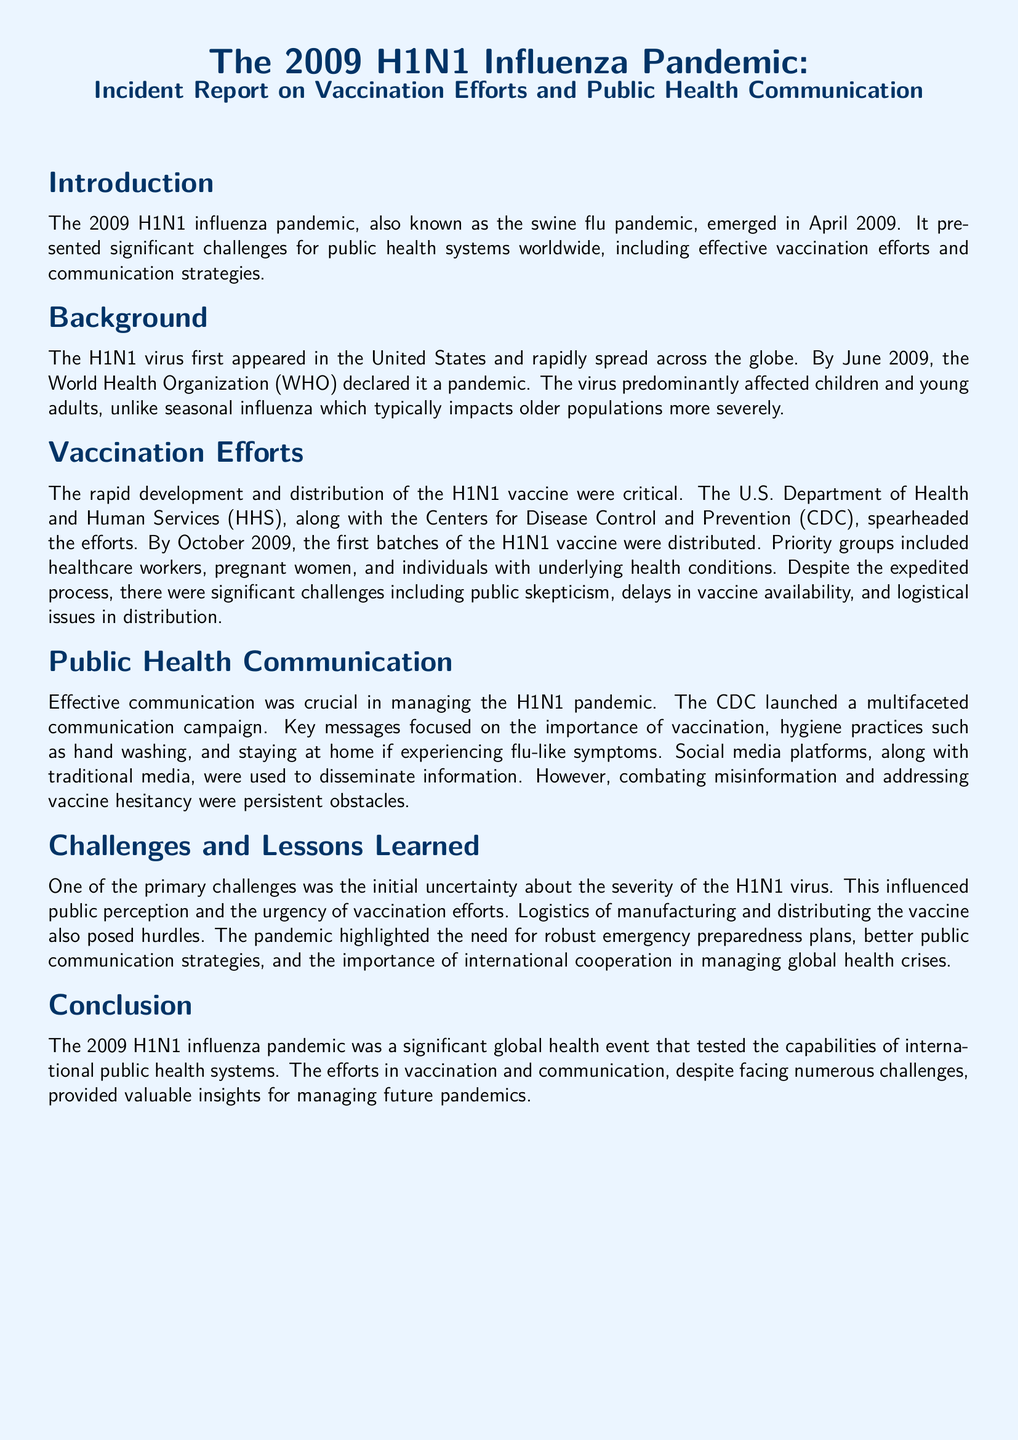What year did the H1N1 pandemic emerge? The document states that the H1N1 influenza pandemic emerged in April 2009.
Answer: 2009 What organization declared H1N1 a pandemic in June 2009? The document mentions that the World Health Organization (WHO) declared it a pandemic.
Answer: World Health Organization Who were the priority groups for the H1N1 vaccine distribution? The document lists healthcare workers, pregnant women, and individuals with underlying health conditions as priority groups.
Answer: Healthcare workers, pregnant women, individuals with underlying health conditions What was one challenge in the vaccination efforts during the H1N1 pandemic? The document indicates that public skepticism was one of the significant challenges faced during vaccination efforts.
Answer: Public skepticism What was a key strategy used in public health communication during the pandemic? The document states that the CDC launched a multifaceted communication campaign as a key strategy.
Answer: Multifaceted communication campaign What was one of the primary challenges regarding public perception of the H1N1 virus? The document highlights that the initial uncertainty about the severity of the H1N1 virus influenced public perception.
Answer: Initial uncertainty What important lesson was highlighted regarding pandemic response? The document emphasizes the importance of robust emergency preparedness plans as a lesson learned.
Answer: Robust emergency preparedness plans What were two platforms used to disseminate information during the H1N1 pandemic? The document mentions both social media platforms and traditional media as used for dissemination.
Answer: Social media, traditional media 